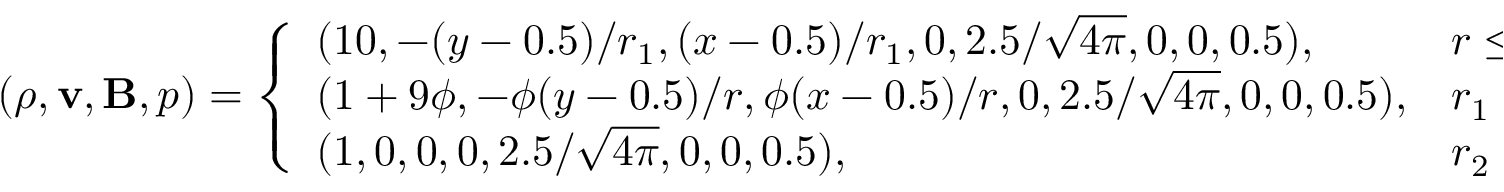<formula> <loc_0><loc_0><loc_500><loc_500>( \rho , v , B , p ) = \left \{ \begin{array} { l l } { ( 1 0 , - ( y - 0 . 5 ) / r _ { 1 } , ( x - 0 . 5 ) / r _ { 1 } , 0 , 2 . 5 / \sqrt { 4 \pi } , 0 , 0 , 0 . 5 ) , } & { r \leq r _ { 1 } , } \\ { ( 1 + 9 \phi , - \phi ( y - 0 . 5 ) / r , \phi ( x - 0 . 5 ) / r , 0 , 2 . 5 / \sqrt { 4 \pi } , 0 , 0 , 0 . 5 ) , } & { r _ { 1 } < r \leq r _ { 2 } , } \\ { ( 1 , 0 , 0 , 0 , 2 . 5 / \sqrt { 4 \pi } , 0 , 0 , 0 . 5 ) , } & { r _ { 2 } < r , } \end{array}</formula> 